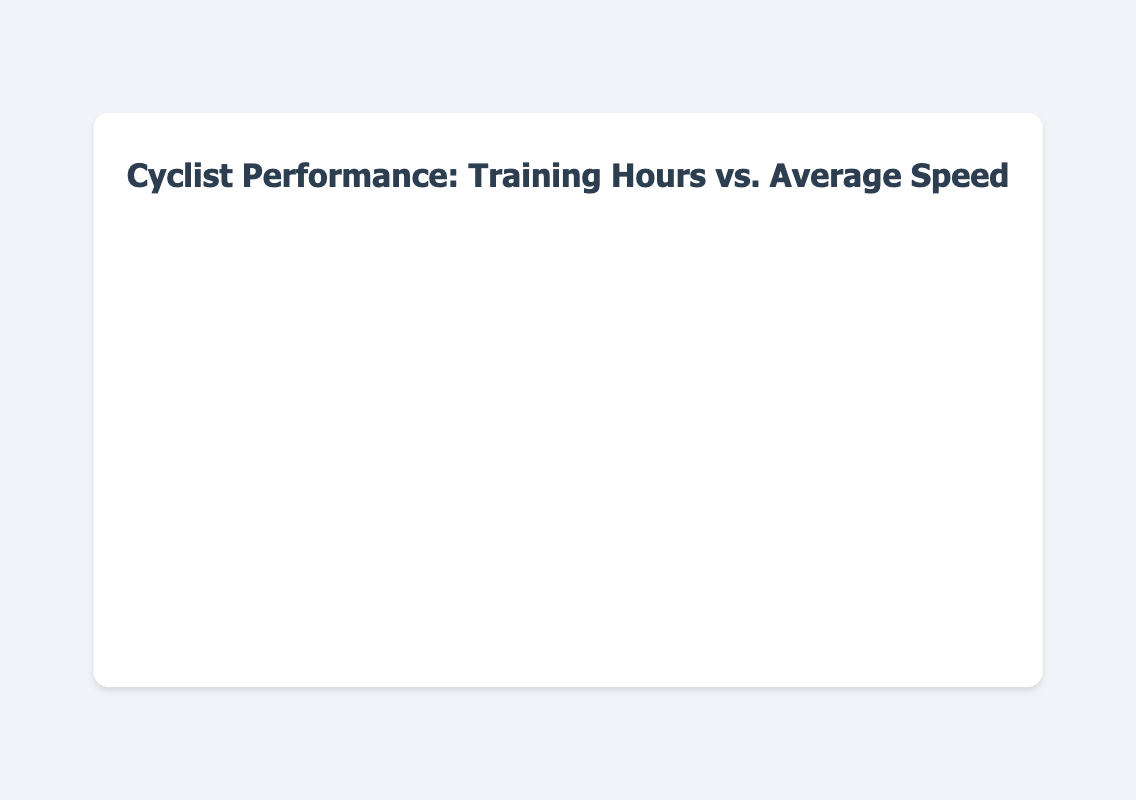What is the title of the chart? The title of the chart is clearly displayed at the top.
Answer: Cyclist Performance: Training Hours vs. Average Speed Which axis represents the Training Hours per Week? The x-axis represents the Training Hours per Week, as indicated by its title.
Answer: x-axis What is the color of the bubbles in the chart? The bubbles in the chart have a transparent blue color.
Answer: transparent blue How many bubbles represent cyclists aged 25-29? There is one bubble for each age group, so we count the entry for the 25-29 age group.
Answer: 1 What is the range of training hours shown on the x-axis? The x-axis ranges from 0 to 25 training hours, as indicated by the axis labels.
Answer: 0 to 25 Which cyclist has the highest average speed? Comparing the y-values (Average Speed) of all the cyclists reveals that Jane Smith has the highest value of 36 km/h.
Answer: Jane Smith How many race wins does the cyclist with 15 training hours per week have? The cyclist with 15 training hours per week is Line Burquier, who has 5 race wins.
Answer: 5 What are the training hours and average speed for the cyclist named Sarah Wilson? Looking at the bubble with Sarah Wilson's name, her training hours are 7, and her average speed is 25 km/h.
Answer: 7 training hours, 25 km/h Which age group has the lowest training hours per week? By examining the x-values, Laura Martinez of the 60-64 age group has the lowest training hours per week at 4 hours.
Answer: 60-64 Compare the average speed of cyclists aged 20-24 and 30-34. Line Burquier (20-24) has an average speed of 35 km/h, while Jane Smith (30-34) has 36 km/h, indicating that the 30-34 age group has a higher average speed.
Answer: 30-34 has higher average speed What is the total number of race wins for cyclists aged 40-44 and 45-49 combined? Robert Brown (40-44) has 2 race wins, and Michael Davis (45-49) has 1 race win, so the total is 2 + 1 = 3 race wins.
Answer: 3 